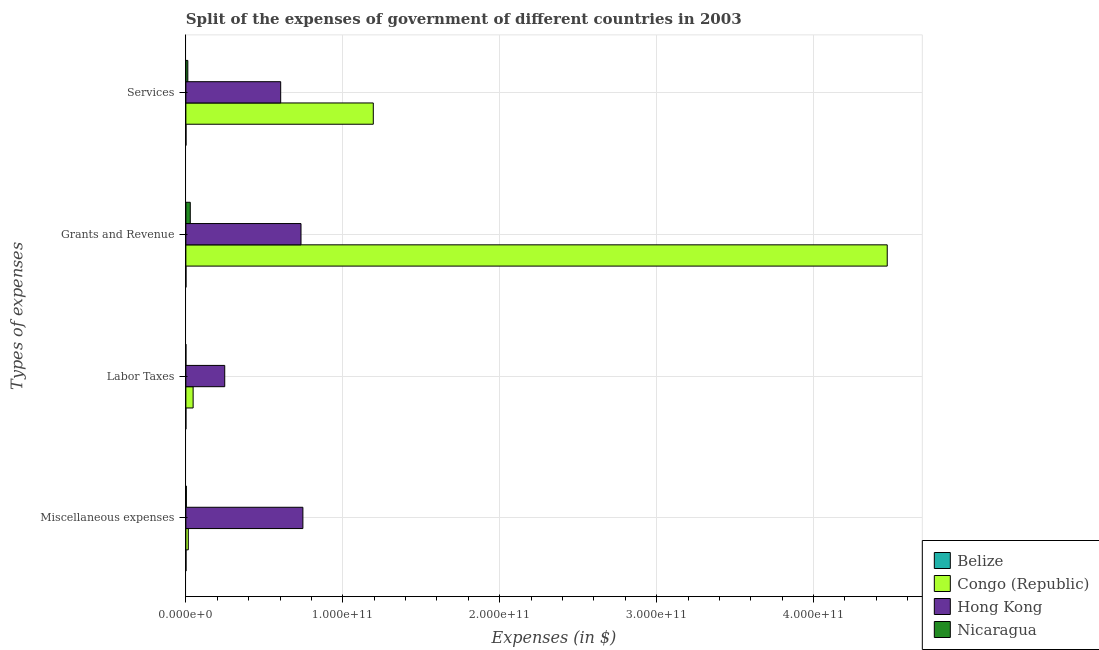Are the number of bars per tick equal to the number of legend labels?
Provide a succinct answer. Yes. Are the number of bars on each tick of the Y-axis equal?
Give a very brief answer. Yes. How many bars are there on the 2nd tick from the top?
Your answer should be compact. 4. How many bars are there on the 4th tick from the bottom?
Keep it short and to the point. 4. What is the label of the 3rd group of bars from the top?
Your response must be concise. Labor Taxes. What is the amount spent on miscellaneous expenses in Nicaragua?
Your answer should be very brief. 3.00e+08. Across all countries, what is the maximum amount spent on grants and revenue?
Your answer should be compact. 4.47e+11. Across all countries, what is the minimum amount spent on miscellaneous expenses?
Your answer should be compact. 7.68e+07. In which country was the amount spent on services maximum?
Keep it short and to the point. Congo (Republic). In which country was the amount spent on services minimum?
Your answer should be compact. Belize. What is the total amount spent on services in the graph?
Give a very brief answer. 1.81e+11. What is the difference between the amount spent on services in Congo (Republic) and that in Nicaragua?
Make the answer very short. 1.18e+11. What is the difference between the amount spent on services in Hong Kong and the amount spent on miscellaneous expenses in Nicaragua?
Make the answer very short. 6.01e+1. What is the average amount spent on grants and revenue per country?
Give a very brief answer. 1.31e+11. What is the difference between the amount spent on miscellaneous expenses and amount spent on labor taxes in Belize?
Ensure brevity in your answer.  7.06e+07. In how many countries, is the amount spent on services greater than 300000000000 $?
Make the answer very short. 0. What is the ratio of the amount spent on labor taxes in Belize to that in Hong Kong?
Provide a short and direct response. 0. What is the difference between the highest and the second highest amount spent on grants and revenue?
Your response must be concise. 3.74e+11. What is the difference between the highest and the lowest amount spent on grants and revenue?
Make the answer very short. 4.47e+11. In how many countries, is the amount spent on services greater than the average amount spent on services taken over all countries?
Offer a terse response. 2. What does the 2nd bar from the top in Services represents?
Ensure brevity in your answer.  Hong Kong. What does the 3rd bar from the bottom in Labor Taxes represents?
Offer a very short reply. Hong Kong. Are all the bars in the graph horizontal?
Your answer should be compact. Yes. How many countries are there in the graph?
Your response must be concise. 4. What is the difference between two consecutive major ticks on the X-axis?
Your answer should be very brief. 1.00e+11. How many legend labels are there?
Offer a very short reply. 4. What is the title of the graph?
Offer a very short reply. Split of the expenses of government of different countries in 2003. What is the label or title of the X-axis?
Keep it short and to the point. Expenses (in $). What is the label or title of the Y-axis?
Your answer should be very brief. Types of expenses. What is the Expenses (in $) in Belize in Miscellaneous expenses?
Ensure brevity in your answer.  7.68e+07. What is the Expenses (in $) in Congo (Republic) in Miscellaneous expenses?
Make the answer very short. 1.55e+09. What is the Expenses (in $) in Hong Kong in Miscellaneous expenses?
Offer a very short reply. 7.46e+1. What is the Expenses (in $) of Nicaragua in Miscellaneous expenses?
Provide a succinct answer. 3.00e+08. What is the Expenses (in $) in Belize in Labor Taxes?
Your response must be concise. 6.14e+06. What is the Expenses (in $) of Congo (Republic) in Labor Taxes?
Provide a succinct answer. 4.61e+09. What is the Expenses (in $) in Hong Kong in Labor Taxes?
Your answer should be compact. 2.48e+1. What is the Expenses (in $) in Nicaragua in Labor Taxes?
Make the answer very short. 1.32e+07. What is the Expenses (in $) of Belize in Grants and Revenue?
Offer a very short reply. 5.82e+07. What is the Expenses (in $) in Congo (Republic) in Grants and Revenue?
Your answer should be compact. 4.47e+11. What is the Expenses (in $) of Hong Kong in Grants and Revenue?
Provide a succinct answer. 7.34e+1. What is the Expenses (in $) in Nicaragua in Grants and Revenue?
Keep it short and to the point. 2.81e+09. What is the Expenses (in $) in Belize in Services?
Ensure brevity in your answer.  7.34e+07. What is the Expenses (in $) of Congo (Republic) in Services?
Give a very brief answer. 1.19e+11. What is the Expenses (in $) of Hong Kong in Services?
Provide a succinct answer. 6.04e+1. What is the Expenses (in $) in Nicaragua in Services?
Your answer should be very brief. 1.25e+09. Across all Types of expenses, what is the maximum Expenses (in $) in Belize?
Your response must be concise. 7.68e+07. Across all Types of expenses, what is the maximum Expenses (in $) in Congo (Republic)?
Offer a terse response. 4.47e+11. Across all Types of expenses, what is the maximum Expenses (in $) in Hong Kong?
Give a very brief answer. 7.46e+1. Across all Types of expenses, what is the maximum Expenses (in $) in Nicaragua?
Your answer should be very brief. 2.81e+09. Across all Types of expenses, what is the minimum Expenses (in $) in Belize?
Keep it short and to the point. 6.14e+06. Across all Types of expenses, what is the minimum Expenses (in $) of Congo (Republic)?
Offer a very short reply. 1.55e+09. Across all Types of expenses, what is the minimum Expenses (in $) in Hong Kong?
Offer a terse response. 2.48e+1. Across all Types of expenses, what is the minimum Expenses (in $) in Nicaragua?
Ensure brevity in your answer.  1.32e+07. What is the total Expenses (in $) of Belize in the graph?
Provide a short and direct response. 2.15e+08. What is the total Expenses (in $) in Congo (Republic) in the graph?
Ensure brevity in your answer.  5.73e+11. What is the total Expenses (in $) in Hong Kong in the graph?
Your answer should be very brief. 2.33e+11. What is the total Expenses (in $) of Nicaragua in the graph?
Ensure brevity in your answer.  4.37e+09. What is the difference between the Expenses (in $) in Belize in Miscellaneous expenses and that in Labor Taxes?
Offer a very short reply. 7.06e+07. What is the difference between the Expenses (in $) in Congo (Republic) in Miscellaneous expenses and that in Labor Taxes?
Provide a short and direct response. -3.06e+09. What is the difference between the Expenses (in $) in Hong Kong in Miscellaneous expenses and that in Labor Taxes?
Offer a terse response. 4.98e+1. What is the difference between the Expenses (in $) in Nicaragua in Miscellaneous expenses and that in Labor Taxes?
Make the answer very short. 2.87e+08. What is the difference between the Expenses (in $) in Belize in Miscellaneous expenses and that in Grants and Revenue?
Give a very brief answer. 1.85e+07. What is the difference between the Expenses (in $) of Congo (Republic) in Miscellaneous expenses and that in Grants and Revenue?
Your answer should be compact. -4.45e+11. What is the difference between the Expenses (in $) in Hong Kong in Miscellaneous expenses and that in Grants and Revenue?
Make the answer very short. 1.20e+09. What is the difference between the Expenses (in $) of Nicaragua in Miscellaneous expenses and that in Grants and Revenue?
Offer a terse response. -2.51e+09. What is the difference between the Expenses (in $) of Belize in Miscellaneous expenses and that in Services?
Ensure brevity in your answer.  3.34e+06. What is the difference between the Expenses (in $) of Congo (Republic) in Miscellaneous expenses and that in Services?
Ensure brevity in your answer.  -1.18e+11. What is the difference between the Expenses (in $) in Hong Kong in Miscellaneous expenses and that in Services?
Give a very brief answer. 1.41e+1. What is the difference between the Expenses (in $) of Nicaragua in Miscellaneous expenses and that in Services?
Your answer should be compact. -9.46e+08. What is the difference between the Expenses (in $) in Belize in Labor Taxes and that in Grants and Revenue?
Offer a very short reply. -5.21e+07. What is the difference between the Expenses (in $) in Congo (Republic) in Labor Taxes and that in Grants and Revenue?
Make the answer very short. -4.42e+11. What is the difference between the Expenses (in $) of Hong Kong in Labor Taxes and that in Grants and Revenue?
Your answer should be compact. -4.86e+1. What is the difference between the Expenses (in $) in Nicaragua in Labor Taxes and that in Grants and Revenue?
Provide a succinct answer. -2.79e+09. What is the difference between the Expenses (in $) of Belize in Labor Taxes and that in Services?
Your answer should be very brief. -6.73e+07. What is the difference between the Expenses (in $) in Congo (Republic) in Labor Taxes and that in Services?
Give a very brief answer. -1.15e+11. What is the difference between the Expenses (in $) in Hong Kong in Labor Taxes and that in Services?
Your answer should be very brief. -3.57e+1. What is the difference between the Expenses (in $) of Nicaragua in Labor Taxes and that in Services?
Your answer should be compact. -1.23e+09. What is the difference between the Expenses (in $) in Belize in Grants and Revenue and that in Services?
Give a very brief answer. -1.52e+07. What is the difference between the Expenses (in $) in Congo (Republic) in Grants and Revenue and that in Services?
Give a very brief answer. 3.28e+11. What is the difference between the Expenses (in $) in Hong Kong in Grants and Revenue and that in Services?
Give a very brief answer. 1.29e+1. What is the difference between the Expenses (in $) of Nicaragua in Grants and Revenue and that in Services?
Offer a terse response. 1.56e+09. What is the difference between the Expenses (in $) of Belize in Miscellaneous expenses and the Expenses (in $) of Congo (Republic) in Labor Taxes?
Your response must be concise. -4.54e+09. What is the difference between the Expenses (in $) of Belize in Miscellaneous expenses and the Expenses (in $) of Hong Kong in Labor Taxes?
Provide a succinct answer. -2.47e+1. What is the difference between the Expenses (in $) of Belize in Miscellaneous expenses and the Expenses (in $) of Nicaragua in Labor Taxes?
Give a very brief answer. 6.36e+07. What is the difference between the Expenses (in $) of Congo (Republic) in Miscellaneous expenses and the Expenses (in $) of Hong Kong in Labor Taxes?
Provide a succinct answer. -2.32e+1. What is the difference between the Expenses (in $) of Congo (Republic) in Miscellaneous expenses and the Expenses (in $) of Nicaragua in Labor Taxes?
Provide a succinct answer. 1.54e+09. What is the difference between the Expenses (in $) in Hong Kong in Miscellaneous expenses and the Expenses (in $) in Nicaragua in Labor Taxes?
Your response must be concise. 7.46e+1. What is the difference between the Expenses (in $) of Belize in Miscellaneous expenses and the Expenses (in $) of Congo (Republic) in Grants and Revenue?
Give a very brief answer. -4.47e+11. What is the difference between the Expenses (in $) in Belize in Miscellaneous expenses and the Expenses (in $) in Hong Kong in Grants and Revenue?
Your response must be concise. -7.33e+1. What is the difference between the Expenses (in $) in Belize in Miscellaneous expenses and the Expenses (in $) in Nicaragua in Grants and Revenue?
Give a very brief answer. -2.73e+09. What is the difference between the Expenses (in $) in Congo (Republic) in Miscellaneous expenses and the Expenses (in $) in Hong Kong in Grants and Revenue?
Your answer should be compact. -7.18e+1. What is the difference between the Expenses (in $) in Congo (Republic) in Miscellaneous expenses and the Expenses (in $) in Nicaragua in Grants and Revenue?
Your response must be concise. -1.26e+09. What is the difference between the Expenses (in $) in Hong Kong in Miscellaneous expenses and the Expenses (in $) in Nicaragua in Grants and Revenue?
Your answer should be very brief. 7.18e+1. What is the difference between the Expenses (in $) of Belize in Miscellaneous expenses and the Expenses (in $) of Congo (Republic) in Services?
Your answer should be compact. -1.19e+11. What is the difference between the Expenses (in $) in Belize in Miscellaneous expenses and the Expenses (in $) in Hong Kong in Services?
Provide a succinct answer. -6.03e+1. What is the difference between the Expenses (in $) in Belize in Miscellaneous expenses and the Expenses (in $) in Nicaragua in Services?
Make the answer very short. -1.17e+09. What is the difference between the Expenses (in $) of Congo (Republic) in Miscellaneous expenses and the Expenses (in $) of Hong Kong in Services?
Your response must be concise. -5.89e+1. What is the difference between the Expenses (in $) in Congo (Republic) in Miscellaneous expenses and the Expenses (in $) in Nicaragua in Services?
Offer a very short reply. 3.04e+08. What is the difference between the Expenses (in $) in Hong Kong in Miscellaneous expenses and the Expenses (in $) in Nicaragua in Services?
Offer a terse response. 7.33e+1. What is the difference between the Expenses (in $) of Belize in Labor Taxes and the Expenses (in $) of Congo (Republic) in Grants and Revenue?
Your answer should be compact. -4.47e+11. What is the difference between the Expenses (in $) in Belize in Labor Taxes and the Expenses (in $) in Hong Kong in Grants and Revenue?
Give a very brief answer. -7.34e+1. What is the difference between the Expenses (in $) of Belize in Labor Taxes and the Expenses (in $) of Nicaragua in Grants and Revenue?
Your answer should be very brief. -2.80e+09. What is the difference between the Expenses (in $) of Congo (Republic) in Labor Taxes and the Expenses (in $) of Hong Kong in Grants and Revenue?
Provide a short and direct response. -6.88e+1. What is the difference between the Expenses (in $) of Congo (Republic) in Labor Taxes and the Expenses (in $) of Nicaragua in Grants and Revenue?
Ensure brevity in your answer.  1.81e+09. What is the difference between the Expenses (in $) in Hong Kong in Labor Taxes and the Expenses (in $) in Nicaragua in Grants and Revenue?
Provide a short and direct response. 2.20e+1. What is the difference between the Expenses (in $) of Belize in Labor Taxes and the Expenses (in $) of Congo (Republic) in Services?
Keep it short and to the point. -1.19e+11. What is the difference between the Expenses (in $) in Belize in Labor Taxes and the Expenses (in $) in Hong Kong in Services?
Provide a succinct answer. -6.04e+1. What is the difference between the Expenses (in $) in Belize in Labor Taxes and the Expenses (in $) in Nicaragua in Services?
Give a very brief answer. -1.24e+09. What is the difference between the Expenses (in $) in Congo (Republic) in Labor Taxes and the Expenses (in $) in Hong Kong in Services?
Provide a short and direct response. -5.58e+1. What is the difference between the Expenses (in $) in Congo (Republic) in Labor Taxes and the Expenses (in $) in Nicaragua in Services?
Your answer should be compact. 3.37e+09. What is the difference between the Expenses (in $) in Hong Kong in Labor Taxes and the Expenses (in $) in Nicaragua in Services?
Provide a short and direct response. 2.35e+1. What is the difference between the Expenses (in $) of Belize in Grants and Revenue and the Expenses (in $) of Congo (Republic) in Services?
Your answer should be compact. -1.19e+11. What is the difference between the Expenses (in $) of Belize in Grants and Revenue and the Expenses (in $) of Hong Kong in Services?
Offer a very short reply. -6.04e+1. What is the difference between the Expenses (in $) in Belize in Grants and Revenue and the Expenses (in $) in Nicaragua in Services?
Your answer should be very brief. -1.19e+09. What is the difference between the Expenses (in $) in Congo (Republic) in Grants and Revenue and the Expenses (in $) in Hong Kong in Services?
Your answer should be very brief. 3.87e+11. What is the difference between the Expenses (in $) of Congo (Republic) in Grants and Revenue and the Expenses (in $) of Nicaragua in Services?
Offer a terse response. 4.46e+11. What is the difference between the Expenses (in $) of Hong Kong in Grants and Revenue and the Expenses (in $) of Nicaragua in Services?
Keep it short and to the point. 7.21e+1. What is the average Expenses (in $) in Belize per Types of expenses?
Provide a succinct answer. 5.36e+07. What is the average Expenses (in $) of Congo (Republic) per Types of expenses?
Give a very brief answer. 1.43e+11. What is the average Expenses (in $) in Hong Kong per Types of expenses?
Offer a very short reply. 5.83e+1. What is the average Expenses (in $) of Nicaragua per Types of expenses?
Keep it short and to the point. 1.09e+09. What is the difference between the Expenses (in $) in Belize and Expenses (in $) in Congo (Republic) in Miscellaneous expenses?
Your answer should be very brief. -1.47e+09. What is the difference between the Expenses (in $) of Belize and Expenses (in $) of Hong Kong in Miscellaneous expenses?
Make the answer very short. -7.45e+1. What is the difference between the Expenses (in $) of Belize and Expenses (in $) of Nicaragua in Miscellaneous expenses?
Give a very brief answer. -2.24e+08. What is the difference between the Expenses (in $) of Congo (Republic) and Expenses (in $) of Hong Kong in Miscellaneous expenses?
Offer a very short reply. -7.30e+1. What is the difference between the Expenses (in $) of Congo (Republic) and Expenses (in $) of Nicaragua in Miscellaneous expenses?
Offer a very short reply. 1.25e+09. What is the difference between the Expenses (in $) in Hong Kong and Expenses (in $) in Nicaragua in Miscellaneous expenses?
Make the answer very short. 7.43e+1. What is the difference between the Expenses (in $) in Belize and Expenses (in $) in Congo (Republic) in Labor Taxes?
Offer a very short reply. -4.61e+09. What is the difference between the Expenses (in $) in Belize and Expenses (in $) in Hong Kong in Labor Taxes?
Your answer should be compact. -2.48e+1. What is the difference between the Expenses (in $) in Belize and Expenses (in $) in Nicaragua in Labor Taxes?
Provide a short and direct response. -7.06e+06. What is the difference between the Expenses (in $) of Congo (Republic) and Expenses (in $) of Hong Kong in Labor Taxes?
Give a very brief answer. -2.01e+1. What is the difference between the Expenses (in $) in Congo (Republic) and Expenses (in $) in Nicaragua in Labor Taxes?
Make the answer very short. 4.60e+09. What is the difference between the Expenses (in $) in Hong Kong and Expenses (in $) in Nicaragua in Labor Taxes?
Provide a succinct answer. 2.47e+1. What is the difference between the Expenses (in $) of Belize and Expenses (in $) of Congo (Republic) in Grants and Revenue?
Your answer should be very brief. -4.47e+11. What is the difference between the Expenses (in $) in Belize and Expenses (in $) in Hong Kong in Grants and Revenue?
Your answer should be compact. -7.33e+1. What is the difference between the Expenses (in $) in Belize and Expenses (in $) in Nicaragua in Grants and Revenue?
Provide a succinct answer. -2.75e+09. What is the difference between the Expenses (in $) of Congo (Republic) and Expenses (in $) of Hong Kong in Grants and Revenue?
Offer a very short reply. 3.74e+11. What is the difference between the Expenses (in $) in Congo (Republic) and Expenses (in $) in Nicaragua in Grants and Revenue?
Ensure brevity in your answer.  4.44e+11. What is the difference between the Expenses (in $) in Hong Kong and Expenses (in $) in Nicaragua in Grants and Revenue?
Provide a succinct answer. 7.06e+1. What is the difference between the Expenses (in $) of Belize and Expenses (in $) of Congo (Republic) in Services?
Offer a terse response. -1.19e+11. What is the difference between the Expenses (in $) of Belize and Expenses (in $) of Hong Kong in Services?
Provide a short and direct response. -6.03e+1. What is the difference between the Expenses (in $) of Belize and Expenses (in $) of Nicaragua in Services?
Make the answer very short. -1.17e+09. What is the difference between the Expenses (in $) in Congo (Republic) and Expenses (in $) in Hong Kong in Services?
Ensure brevity in your answer.  5.90e+1. What is the difference between the Expenses (in $) in Congo (Republic) and Expenses (in $) in Nicaragua in Services?
Give a very brief answer. 1.18e+11. What is the difference between the Expenses (in $) of Hong Kong and Expenses (in $) of Nicaragua in Services?
Give a very brief answer. 5.92e+1. What is the ratio of the Expenses (in $) in Belize in Miscellaneous expenses to that in Labor Taxes?
Make the answer very short. 12.5. What is the ratio of the Expenses (in $) in Congo (Republic) in Miscellaneous expenses to that in Labor Taxes?
Your answer should be compact. 0.34. What is the ratio of the Expenses (in $) in Hong Kong in Miscellaneous expenses to that in Labor Taxes?
Offer a very short reply. 3.01. What is the ratio of the Expenses (in $) of Nicaragua in Miscellaneous expenses to that in Labor Taxes?
Make the answer very short. 22.76. What is the ratio of the Expenses (in $) of Belize in Miscellaneous expenses to that in Grants and Revenue?
Your answer should be very brief. 1.32. What is the ratio of the Expenses (in $) of Congo (Republic) in Miscellaneous expenses to that in Grants and Revenue?
Give a very brief answer. 0. What is the ratio of the Expenses (in $) of Hong Kong in Miscellaneous expenses to that in Grants and Revenue?
Your answer should be compact. 1.02. What is the ratio of the Expenses (in $) of Nicaragua in Miscellaneous expenses to that in Grants and Revenue?
Ensure brevity in your answer.  0.11. What is the ratio of the Expenses (in $) of Belize in Miscellaneous expenses to that in Services?
Offer a terse response. 1.05. What is the ratio of the Expenses (in $) in Congo (Republic) in Miscellaneous expenses to that in Services?
Offer a terse response. 0.01. What is the ratio of the Expenses (in $) in Hong Kong in Miscellaneous expenses to that in Services?
Offer a terse response. 1.23. What is the ratio of the Expenses (in $) of Nicaragua in Miscellaneous expenses to that in Services?
Provide a succinct answer. 0.24. What is the ratio of the Expenses (in $) of Belize in Labor Taxes to that in Grants and Revenue?
Offer a very short reply. 0.11. What is the ratio of the Expenses (in $) of Congo (Republic) in Labor Taxes to that in Grants and Revenue?
Offer a very short reply. 0.01. What is the ratio of the Expenses (in $) in Hong Kong in Labor Taxes to that in Grants and Revenue?
Offer a very short reply. 0.34. What is the ratio of the Expenses (in $) of Nicaragua in Labor Taxes to that in Grants and Revenue?
Your answer should be very brief. 0. What is the ratio of the Expenses (in $) of Belize in Labor Taxes to that in Services?
Provide a short and direct response. 0.08. What is the ratio of the Expenses (in $) of Congo (Republic) in Labor Taxes to that in Services?
Keep it short and to the point. 0.04. What is the ratio of the Expenses (in $) of Hong Kong in Labor Taxes to that in Services?
Your response must be concise. 0.41. What is the ratio of the Expenses (in $) of Nicaragua in Labor Taxes to that in Services?
Offer a terse response. 0.01. What is the ratio of the Expenses (in $) of Belize in Grants and Revenue to that in Services?
Your answer should be very brief. 0.79. What is the ratio of the Expenses (in $) in Congo (Republic) in Grants and Revenue to that in Services?
Make the answer very short. 3.74. What is the ratio of the Expenses (in $) in Hong Kong in Grants and Revenue to that in Services?
Give a very brief answer. 1.21. What is the ratio of the Expenses (in $) of Nicaragua in Grants and Revenue to that in Services?
Provide a succinct answer. 2.25. What is the difference between the highest and the second highest Expenses (in $) in Belize?
Provide a short and direct response. 3.34e+06. What is the difference between the highest and the second highest Expenses (in $) in Congo (Republic)?
Your response must be concise. 3.28e+11. What is the difference between the highest and the second highest Expenses (in $) in Hong Kong?
Your response must be concise. 1.20e+09. What is the difference between the highest and the second highest Expenses (in $) in Nicaragua?
Provide a short and direct response. 1.56e+09. What is the difference between the highest and the lowest Expenses (in $) of Belize?
Keep it short and to the point. 7.06e+07. What is the difference between the highest and the lowest Expenses (in $) of Congo (Republic)?
Provide a short and direct response. 4.45e+11. What is the difference between the highest and the lowest Expenses (in $) in Hong Kong?
Offer a very short reply. 4.98e+1. What is the difference between the highest and the lowest Expenses (in $) in Nicaragua?
Offer a very short reply. 2.79e+09. 